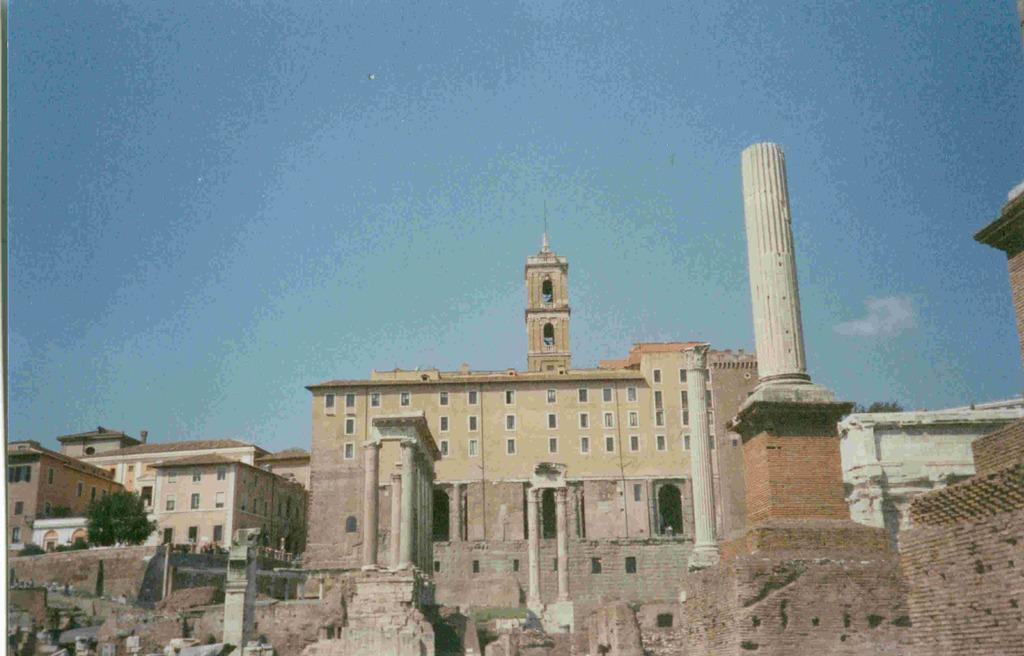What type of structures can be seen in the image? A: There are buildings in the image. What natural elements are present in the image? There are trees in the image. What architectural features can be observed in the buildings? There are windows and pillars in the image. What is the boundary between the buildings and the sky? There is a wall in the image. What can be seen in the background of the image? The sky is visible in the background of the image, and clouds are present in the sky. What type of spade is being used to dig a hole in the image? There is no spade or hole present in the image. Can you tell me who the partner of the person in the image is? There is no person or partner mentioned in the image. 